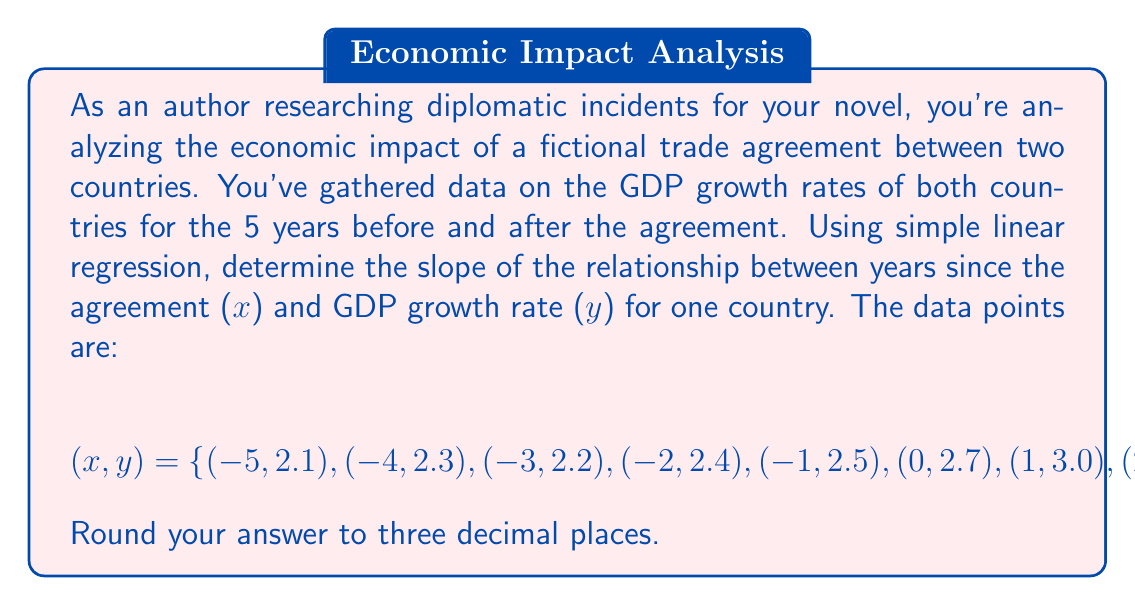Give your solution to this math problem. To find the slope of the linear regression line, we'll use the formula:

$$m = \frac{n\sum xy - \sum x \sum y}{n\sum x^2 - (\sum x)^2}$$

Where:
$n$ is the number of data points
$x$ is the years since the agreement
$y$ is the GDP growth rate

Step 1: Calculate the necessary sums:
$n = 11$
$\sum x = -5 - 4 - 3 - 2 - 1 + 0 + 1 + 2 + 3 + 4 + 5 = 0$
$\sum y = 2.1 + 2.3 + 2.2 + 2.4 + 2.5 + 2.7 + 3.0 + 3.2 + 3.5 + 3.7 + 3.9 = 31.5$
$\sum xy = (-5)(2.1) + (-4)(2.3) + ... + (4)(3.7) + (5)(3.9) = 38.5$
$\sum x^2 = (-5)^2 + (-4)^2 + ... + 4^2 + 5^2 = 110$

Step 2: Plug these values into the slope formula:

$$m = \frac{11(38.5) - (0)(31.5)}{11(110) - (0)^2}$$

Step 3: Simplify:

$$m = \frac{423.5}{1210} \approx 0.350$$

Rounding to three decimal places, we get 0.350.
Answer: 0.350 